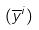<formula> <loc_0><loc_0><loc_500><loc_500>( \overline { y } ^ { i } )</formula> 